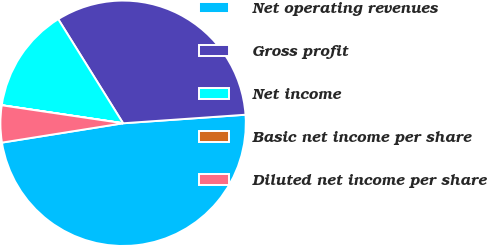Convert chart. <chart><loc_0><loc_0><loc_500><loc_500><pie_chart><fcel>Net operating revenues<fcel>Gross profit<fcel>Net income<fcel>Basic net income per share<fcel>Diluted net income per share<nl><fcel>48.59%<fcel>32.76%<fcel>13.78%<fcel>0.01%<fcel>4.86%<nl></chart> 